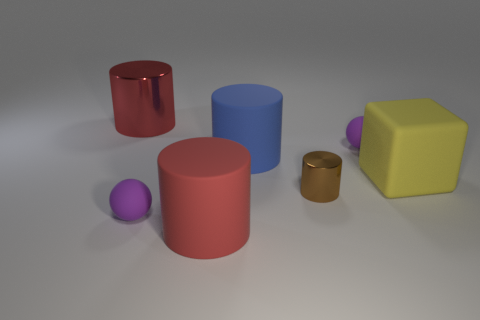There is another thing that is the same color as the big shiny object; what size is it?
Keep it short and to the point. Large. There is a rubber cylinder behind the small purple matte ball that is left of the big blue rubber cylinder; what color is it?
Your answer should be compact. Blue. How many other objects are the same color as the big cube?
Keep it short and to the point. 0. The red rubber object has what size?
Offer a very short reply. Large. Is the number of small purple things behind the large yellow rubber cube greater than the number of large rubber cylinders that are behind the big blue rubber thing?
Provide a succinct answer. Yes. There is a small purple ball that is in front of the big matte cube; what number of big red objects are on the left side of it?
Your answer should be compact. 1. Does the red object in front of the large metal cylinder have the same shape as the red metallic thing?
Your response must be concise. Yes. There is a small brown object that is the same shape as the blue rubber thing; what is it made of?
Your answer should be very brief. Metal. What number of metal objects have the same size as the matte cube?
Your answer should be very brief. 1. What color is the large matte object that is behind the tiny cylinder and to the left of the large yellow object?
Ensure brevity in your answer.  Blue. 